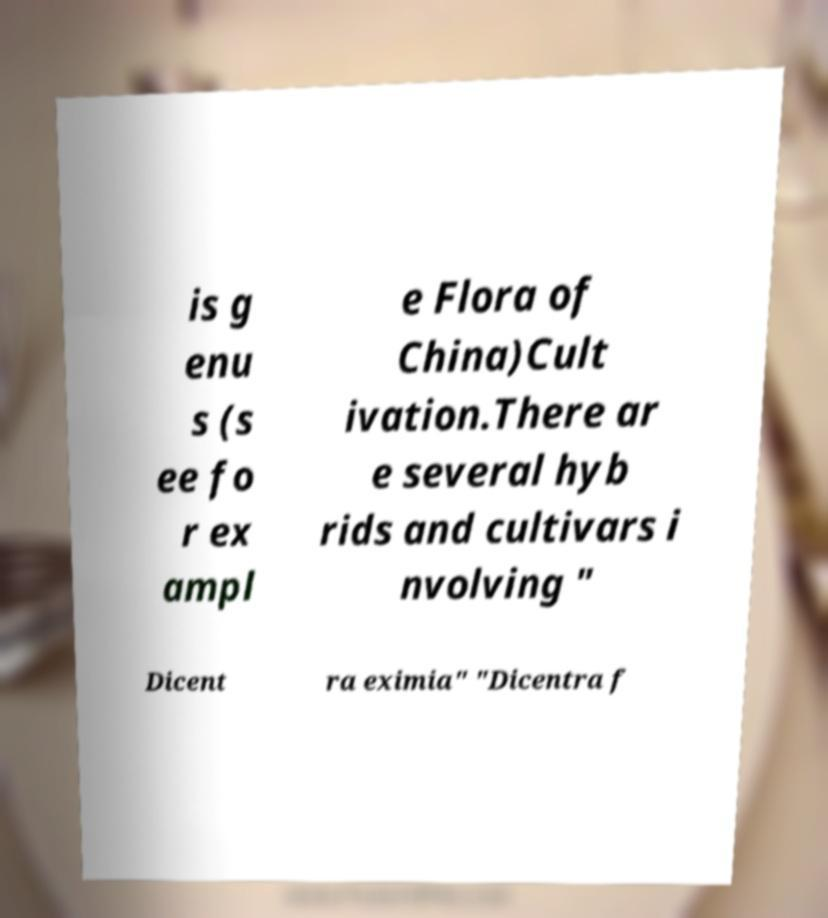Could you extract and type out the text from this image? is g enu s (s ee fo r ex ampl e Flora of China)Cult ivation.There ar e several hyb rids and cultivars i nvolving " Dicent ra eximia" "Dicentra f 